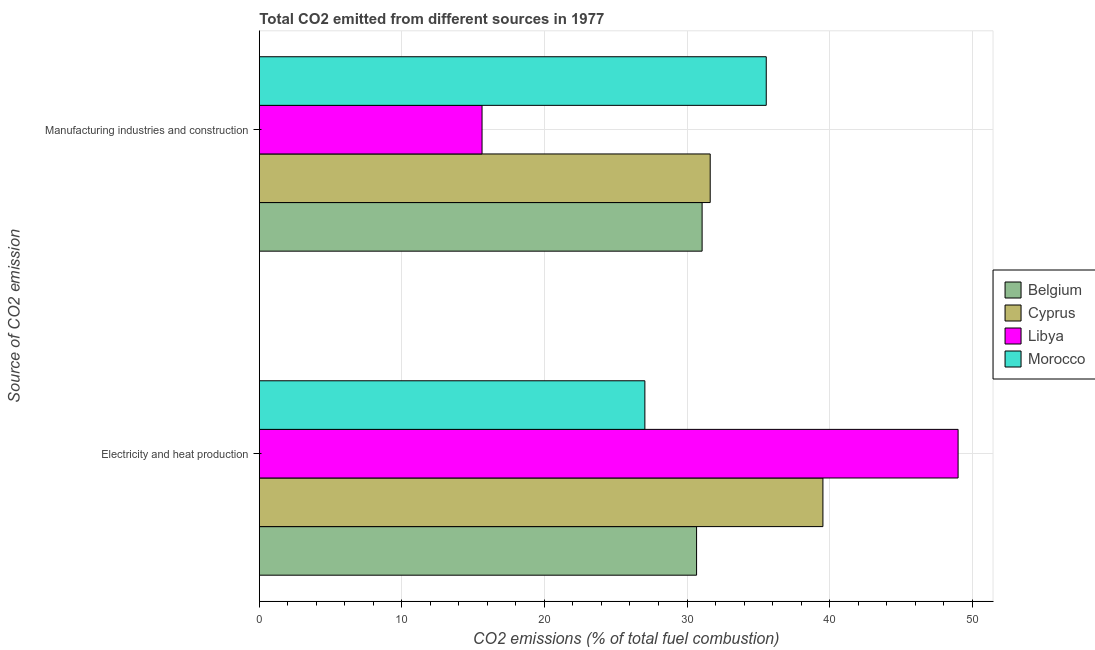How many different coloured bars are there?
Give a very brief answer. 4. How many groups of bars are there?
Your answer should be very brief. 2. What is the label of the 1st group of bars from the top?
Offer a very short reply. Manufacturing industries and construction. What is the co2 emissions due to electricity and heat production in Belgium?
Give a very brief answer. 30.67. Across all countries, what is the maximum co2 emissions due to manufacturing industries?
Keep it short and to the point. 35.56. Across all countries, what is the minimum co2 emissions due to electricity and heat production?
Offer a terse response. 27.05. In which country was the co2 emissions due to electricity and heat production maximum?
Ensure brevity in your answer.  Libya. In which country was the co2 emissions due to electricity and heat production minimum?
Your answer should be compact. Morocco. What is the total co2 emissions due to manufacturing industries in the graph?
Provide a succinct answer. 113.87. What is the difference between the co2 emissions due to electricity and heat production in Belgium and that in Cyprus?
Give a very brief answer. -8.86. What is the difference between the co2 emissions due to electricity and heat production in Cyprus and the co2 emissions due to manufacturing industries in Belgium?
Your answer should be very brief. 8.47. What is the average co2 emissions due to electricity and heat production per country?
Your answer should be very brief. 36.57. What is the difference between the co2 emissions due to manufacturing industries and co2 emissions due to electricity and heat production in Libya?
Offer a terse response. -33.4. What is the ratio of the co2 emissions due to electricity and heat production in Morocco to that in Cyprus?
Provide a short and direct response. 0.68. In how many countries, is the co2 emissions due to manufacturing industries greater than the average co2 emissions due to manufacturing industries taken over all countries?
Provide a short and direct response. 3. What does the 4th bar from the bottom in Manufacturing industries and construction represents?
Your response must be concise. Morocco. Are all the bars in the graph horizontal?
Make the answer very short. Yes. What is the difference between two consecutive major ticks on the X-axis?
Make the answer very short. 10. Does the graph contain any zero values?
Provide a succinct answer. No. How many legend labels are there?
Provide a short and direct response. 4. How are the legend labels stacked?
Your answer should be compact. Vertical. What is the title of the graph?
Ensure brevity in your answer.  Total CO2 emitted from different sources in 1977. Does "European Union" appear as one of the legend labels in the graph?
Ensure brevity in your answer.  No. What is the label or title of the X-axis?
Provide a succinct answer. CO2 emissions (% of total fuel combustion). What is the label or title of the Y-axis?
Give a very brief answer. Source of CO2 emission. What is the CO2 emissions (% of total fuel combustion) of Belgium in Electricity and heat production?
Ensure brevity in your answer.  30.67. What is the CO2 emissions (% of total fuel combustion) of Cyprus in Electricity and heat production?
Your response must be concise. 39.53. What is the CO2 emissions (% of total fuel combustion) of Libya in Electricity and heat production?
Provide a short and direct response. 49.02. What is the CO2 emissions (% of total fuel combustion) of Morocco in Electricity and heat production?
Your response must be concise. 27.05. What is the CO2 emissions (% of total fuel combustion) of Belgium in Manufacturing industries and construction?
Give a very brief answer. 31.06. What is the CO2 emissions (% of total fuel combustion) of Cyprus in Manufacturing industries and construction?
Your answer should be very brief. 31.63. What is the CO2 emissions (% of total fuel combustion) of Libya in Manufacturing industries and construction?
Offer a terse response. 15.62. What is the CO2 emissions (% of total fuel combustion) in Morocco in Manufacturing industries and construction?
Provide a succinct answer. 35.56. Across all Source of CO2 emission, what is the maximum CO2 emissions (% of total fuel combustion) in Belgium?
Ensure brevity in your answer.  31.06. Across all Source of CO2 emission, what is the maximum CO2 emissions (% of total fuel combustion) of Cyprus?
Your answer should be compact. 39.53. Across all Source of CO2 emission, what is the maximum CO2 emissions (% of total fuel combustion) of Libya?
Ensure brevity in your answer.  49.02. Across all Source of CO2 emission, what is the maximum CO2 emissions (% of total fuel combustion) in Morocco?
Ensure brevity in your answer.  35.56. Across all Source of CO2 emission, what is the minimum CO2 emissions (% of total fuel combustion) in Belgium?
Ensure brevity in your answer.  30.67. Across all Source of CO2 emission, what is the minimum CO2 emissions (% of total fuel combustion) of Cyprus?
Your answer should be compact. 31.63. Across all Source of CO2 emission, what is the minimum CO2 emissions (% of total fuel combustion) in Libya?
Make the answer very short. 15.62. Across all Source of CO2 emission, what is the minimum CO2 emissions (% of total fuel combustion) in Morocco?
Your answer should be very brief. 27.05. What is the total CO2 emissions (% of total fuel combustion) in Belgium in the graph?
Offer a very short reply. 61.73. What is the total CO2 emissions (% of total fuel combustion) in Cyprus in the graph?
Give a very brief answer. 71.16. What is the total CO2 emissions (% of total fuel combustion) in Libya in the graph?
Make the answer very short. 64.64. What is the total CO2 emissions (% of total fuel combustion) in Morocco in the graph?
Your answer should be very brief. 62.6. What is the difference between the CO2 emissions (% of total fuel combustion) in Belgium in Electricity and heat production and that in Manufacturing industries and construction?
Provide a succinct answer. -0.39. What is the difference between the CO2 emissions (% of total fuel combustion) in Cyprus in Electricity and heat production and that in Manufacturing industries and construction?
Provide a short and direct response. 7.91. What is the difference between the CO2 emissions (% of total fuel combustion) of Libya in Electricity and heat production and that in Manufacturing industries and construction?
Give a very brief answer. 33.4. What is the difference between the CO2 emissions (% of total fuel combustion) in Morocco in Electricity and heat production and that in Manufacturing industries and construction?
Keep it short and to the point. -8.51. What is the difference between the CO2 emissions (% of total fuel combustion) in Belgium in Electricity and heat production and the CO2 emissions (% of total fuel combustion) in Cyprus in Manufacturing industries and construction?
Make the answer very short. -0.96. What is the difference between the CO2 emissions (% of total fuel combustion) in Belgium in Electricity and heat production and the CO2 emissions (% of total fuel combustion) in Libya in Manufacturing industries and construction?
Ensure brevity in your answer.  15.05. What is the difference between the CO2 emissions (% of total fuel combustion) in Belgium in Electricity and heat production and the CO2 emissions (% of total fuel combustion) in Morocco in Manufacturing industries and construction?
Provide a short and direct response. -4.89. What is the difference between the CO2 emissions (% of total fuel combustion) in Cyprus in Electricity and heat production and the CO2 emissions (% of total fuel combustion) in Libya in Manufacturing industries and construction?
Your answer should be very brief. 23.91. What is the difference between the CO2 emissions (% of total fuel combustion) of Cyprus in Electricity and heat production and the CO2 emissions (% of total fuel combustion) of Morocco in Manufacturing industries and construction?
Your answer should be very brief. 3.98. What is the difference between the CO2 emissions (% of total fuel combustion) of Libya in Electricity and heat production and the CO2 emissions (% of total fuel combustion) of Morocco in Manufacturing industries and construction?
Make the answer very short. 13.46. What is the average CO2 emissions (% of total fuel combustion) in Belgium per Source of CO2 emission?
Provide a short and direct response. 30.87. What is the average CO2 emissions (% of total fuel combustion) of Cyprus per Source of CO2 emission?
Your answer should be compact. 35.58. What is the average CO2 emissions (% of total fuel combustion) in Libya per Source of CO2 emission?
Offer a very short reply. 32.32. What is the average CO2 emissions (% of total fuel combustion) of Morocco per Source of CO2 emission?
Offer a very short reply. 31.3. What is the difference between the CO2 emissions (% of total fuel combustion) of Belgium and CO2 emissions (% of total fuel combustion) of Cyprus in Electricity and heat production?
Offer a very short reply. -8.86. What is the difference between the CO2 emissions (% of total fuel combustion) in Belgium and CO2 emissions (% of total fuel combustion) in Libya in Electricity and heat production?
Keep it short and to the point. -18.35. What is the difference between the CO2 emissions (% of total fuel combustion) in Belgium and CO2 emissions (% of total fuel combustion) in Morocco in Electricity and heat production?
Your response must be concise. 3.63. What is the difference between the CO2 emissions (% of total fuel combustion) of Cyprus and CO2 emissions (% of total fuel combustion) of Libya in Electricity and heat production?
Provide a succinct answer. -9.48. What is the difference between the CO2 emissions (% of total fuel combustion) of Cyprus and CO2 emissions (% of total fuel combustion) of Morocco in Electricity and heat production?
Give a very brief answer. 12.49. What is the difference between the CO2 emissions (% of total fuel combustion) in Libya and CO2 emissions (% of total fuel combustion) in Morocco in Electricity and heat production?
Make the answer very short. 21.97. What is the difference between the CO2 emissions (% of total fuel combustion) in Belgium and CO2 emissions (% of total fuel combustion) in Cyprus in Manufacturing industries and construction?
Your answer should be compact. -0.57. What is the difference between the CO2 emissions (% of total fuel combustion) of Belgium and CO2 emissions (% of total fuel combustion) of Libya in Manufacturing industries and construction?
Your response must be concise. 15.44. What is the difference between the CO2 emissions (% of total fuel combustion) of Belgium and CO2 emissions (% of total fuel combustion) of Morocco in Manufacturing industries and construction?
Ensure brevity in your answer.  -4.5. What is the difference between the CO2 emissions (% of total fuel combustion) in Cyprus and CO2 emissions (% of total fuel combustion) in Libya in Manufacturing industries and construction?
Make the answer very short. 16.01. What is the difference between the CO2 emissions (% of total fuel combustion) of Cyprus and CO2 emissions (% of total fuel combustion) of Morocco in Manufacturing industries and construction?
Make the answer very short. -3.93. What is the difference between the CO2 emissions (% of total fuel combustion) of Libya and CO2 emissions (% of total fuel combustion) of Morocco in Manufacturing industries and construction?
Your answer should be very brief. -19.94. What is the ratio of the CO2 emissions (% of total fuel combustion) in Belgium in Electricity and heat production to that in Manufacturing industries and construction?
Give a very brief answer. 0.99. What is the ratio of the CO2 emissions (% of total fuel combustion) of Libya in Electricity and heat production to that in Manufacturing industries and construction?
Offer a terse response. 3.14. What is the ratio of the CO2 emissions (% of total fuel combustion) in Morocco in Electricity and heat production to that in Manufacturing industries and construction?
Make the answer very short. 0.76. What is the difference between the highest and the second highest CO2 emissions (% of total fuel combustion) in Belgium?
Your response must be concise. 0.39. What is the difference between the highest and the second highest CO2 emissions (% of total fuel combustion) in Cyprus?
Provide a short and direct response. 7.91. What is the difference between the highest and the second highest CO2 emissions (% of total fuel combustion) of Libya?
Your response must be concise. 33.4. What is the difference between the highest and the second highest CO2 emissions (% of total fuel combustion) of Morocco?
Offer a terse response. 8.51. What is the difference between the highest and the lowest CO2 emissions (% of total fuel combustion) in Belgium?
Keep it short and to the point. 0.39. What is the difference between the highest and the lowest CO2 emissions (% of total fuel combustion) in Cyprus?
Give a very brief answer. 7.91. What is the difference between the highest and the lowest CO2 emissions (% of total fuel combustion) in Libya?
Offer a terse response. 33.4. What is the difference between the highest and the lowest CO2 emissions (% of total fuel combustion) in Morocco?
Your answer should be very brief. 8.51. 